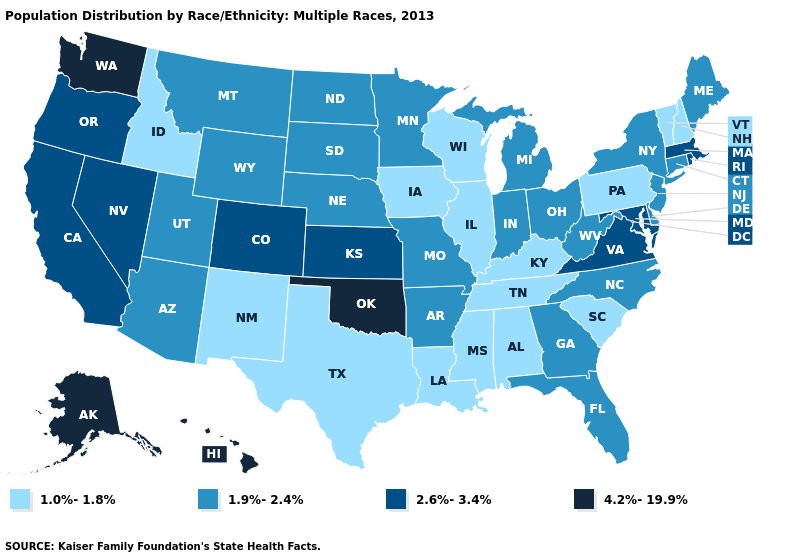How many symbols are there in the legend?
Concise answer only. 4. What is the value of Alabama?
Be succinct. 1.0%-1.8%. Name the states that have a value in the range 1.9%-2.4%?
Be succinct. Arizona, Arkansas, Connecticut, Delaware, Florida, Georgia, Indiana, Maine, Michigan, Minnesota, Missouri, Montana, Nebraska, New Jersey, New York, North Carolina, North Dakota, Ohio, South Dakota, Utah, West Virginia, Wyoming. What is the lowest value in states that border Utah?
Concise answer only. 1.0%-1.8%. What is the lowest value in the MidWest?
Answer briefly. 1.0%-1.8%. Which states hav the highest value in the South?
Short answer required. Oklahoma. What is the value of Nevada?
Concise answer only. 2.6%-3.4%. Does the map have missing data?
Keep it brief. No. Which states have the lowest value in the West?
Quick response, please. Idaho, New Mexico. What is the lowest value in states that border Massachusetts?
Concise answer only. 1.0%-1.8%. Does South Carolina have the highest value in the South?
Be succinct. No. Among the states that border Maine , which have the highest value?
Quick response, please. New Hampshire. Does the first symbol in the legend represent the smallest category?
Be succinct. Yes. What is the lowest value in states that border Louisiana?
Keep it brief. 1.0%-1.8%. How many symbols are there in the legend?
Be succinct. 4. 